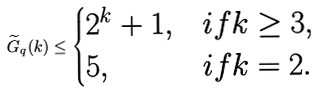<formula> <loc_0><loc_0><loc_500><loc_500>\widetilde { G } _ { q } ( k ) \leq \begin{cases} 2 ^ { k } + 1 , & i f k \geq 3 , \\ 5 , & i f k = 2 . \end{cases} \\</formula> 